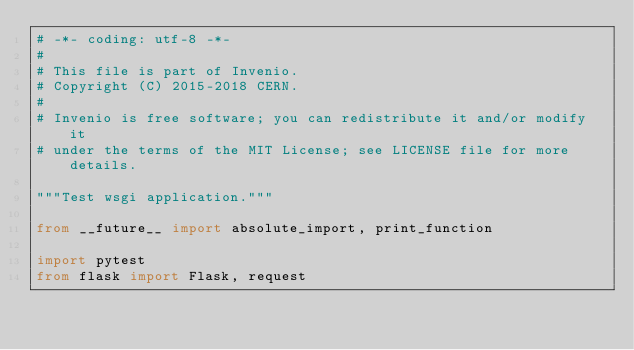<code> <loc_0><loc_0><loc_500><loc_500><_Python_># -*- coding: utf-8 -*-
#
# This file is part of Invenio.
# Copyright (C) 2015-2018 CERN.
#
# Invenio is free software; you can redistribute it and/or modify it
# under the terms of the MIT License; see LICENSE file for more details.

"""Test wsgi application."""

from __future__ import absolute_import, print_function

import pytest
from flask import Flask, request
</code> 